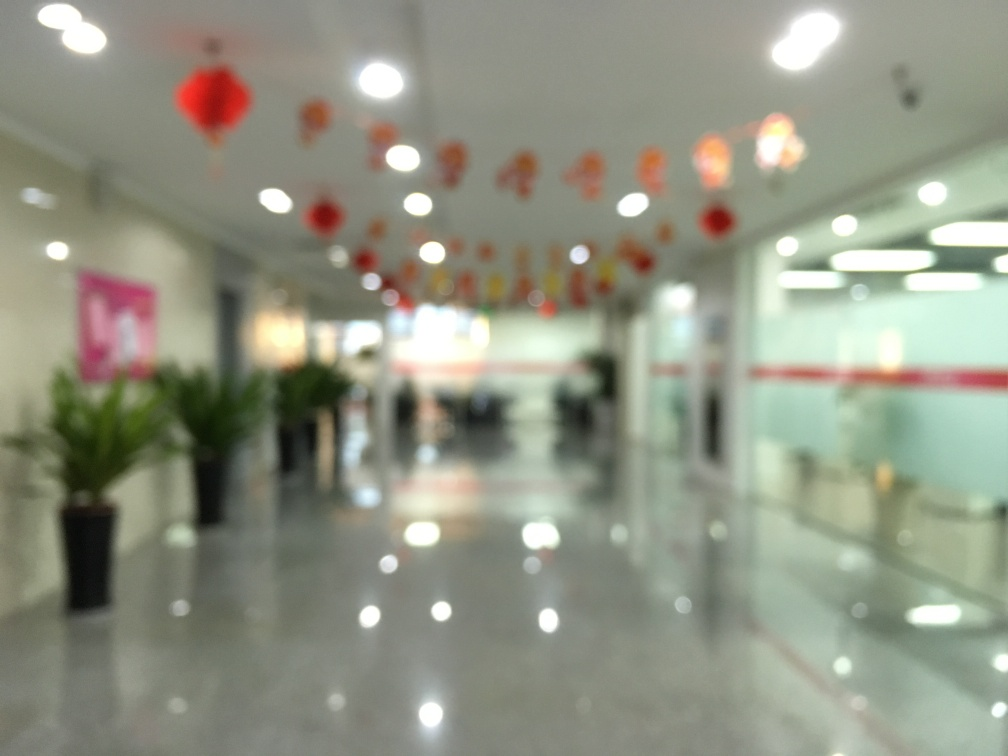Can you guess why the image might be intentionally blurred? The image could be intentionally blurred for artistic effect, to convey a sense of movement or activity, or to focus on the festive atmosphere rather than the specific details of the space. It could also be a privacy measure to obscure faces or sensitive information. How does the blur affect the overall mood or atmosphere of the picture? The blur gives the image a dreamy, ethereal quality, suggesting a lively and bustling environment that is inviting and warm. The festive decorations are still noticeable and add to the celebratory ambiance. 